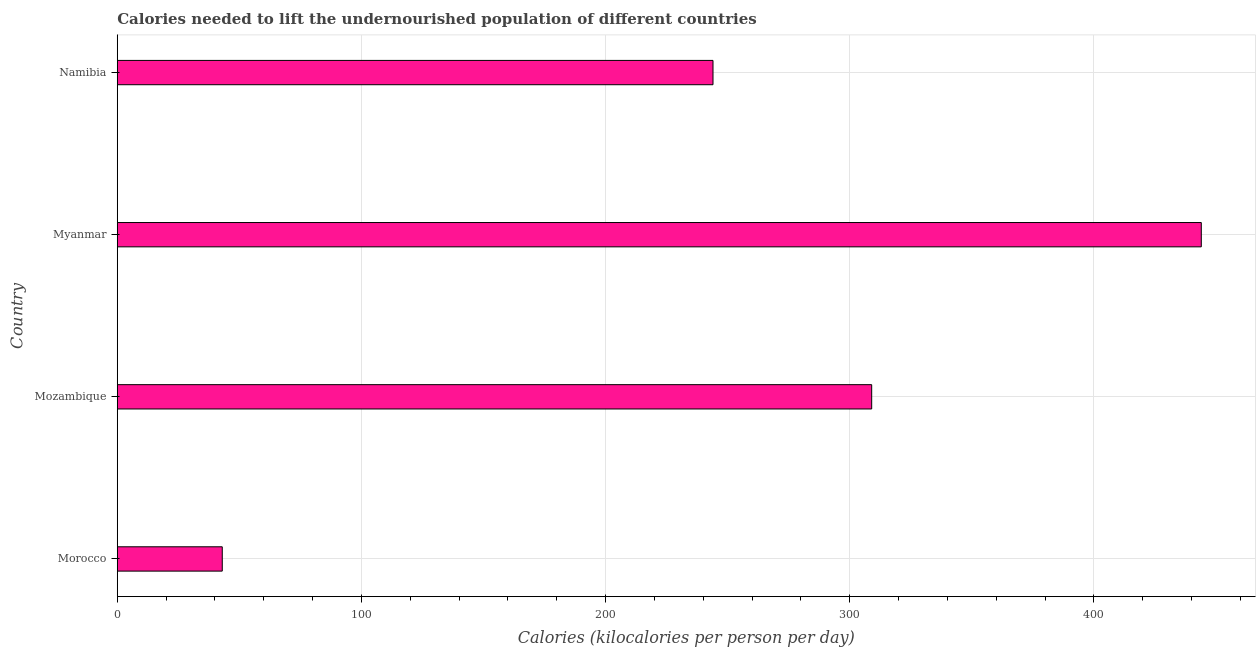Does the graph contain any zero values?
Your answer should be very brief. No. What is the title of the graph?
Provide a short and direct response. Calories needed to lift the undernourished population of different countries. What is the label or title of the X-axis?
Your answer should be very brief. Calories (kilocalories per person per day). What is the depth of food deficit in Morocco?
Your answer should be compact. 43. Across all countries, what is the maximum depth of food deficit?
Provide a succinct answer. 444. In which country was the depth of food deficit maximum?
Keep it short and to the point. Myanmar. In which country was the depth of food deficit minimum?
Your answer should be compact. Morocco. What is the sum of the depth of food deficit?
Offer a terse response. 1040. What is the difference between the depth of food deficit in Morocco and Mozambique?
Provide a succinct answer. -266. What is the average depth of food deficit per country?
Your response must be concise. 260. What is the median depth of food deficit?
Offer a very short reply. 276.5. What is the ratio of the depth of food deficit in Morocco to that in Mozambique?
Your response must be concise. 0.14. Is the depth of food deficit in Mozambique less than that in Namibia?
Your answer should be compact. No. What is the difference between the highest and the second highest depth of food deficit?
Offer a terse response. 135. Is the sum of the depth of food deficit in Morocco and Mozambique greater than the maximum depth of food deficit across all countries?
Offer a very short reply. No. What is the difference between the highest and the lowest depth of food deficit?
Give a very brief answer. 401. Are all the bars in the graph horizontal?
Ensure brevity in your answer.  Yes. Are the values on the major ticks of X-axis written in scientific E-notation?
Provide a short and direct response. No. What is the Calories (kilocalories per person per day) of Morocco?
Offer a terse response. 43. What is the Calories (kilocalories per person per day) in Mozambique?
Offer a very short reply. 309. What is the Calories (kilocalories per person per day) of Myanmar?
Your response must be concise. 444. What is the Calories (kilocalories per person per day) in Namibia?
Your answer should be very brief. 244. What is the difference between the Calories (kilocalories per person per day) in Morocco and Mozambique?
Provide a succinct answer. -266. What is the difference between the Calories (kilocalories per person per day) in Morocco and Myanmar?
Keep it short and to the point. -401. What is the difference between the Calories (kilocalories per person per day) in Morocco and Namibia?
Give a very brief answer. -201. What is the difference between the Calories (kilocalories per person per day) in Mozambique and Myanmar?
Offer a very short reply. -135. What is the ratio of the Calories (kilocalories per person per day) in Morocco to that in Mozambique?
Your response must be concise. 0.14. What is the ratio of the Calories (kilocalories per person per day) in Morocco to that in Myanmar?
Give a very brief answer. 0.1. What is the ratio of the Calories (kilocalories per person per day) in Morocco to that in Namibia?
Keep it short and to the point. 0.18. What is the ratio of the Calories (kilocalories per person per day) in Mozambique to that in Myanmar?
Offer a terse response. 0.7. What is the ratio of the Calories (kilocalories per person per day) in Mozambique to that in Namibia?
Your answer should be very brief. 1.27. What is the ratio of the Calories (kilocalories per person per day) in Myanmar to that in Namibia?
Give a very brief answer. 1.82. 